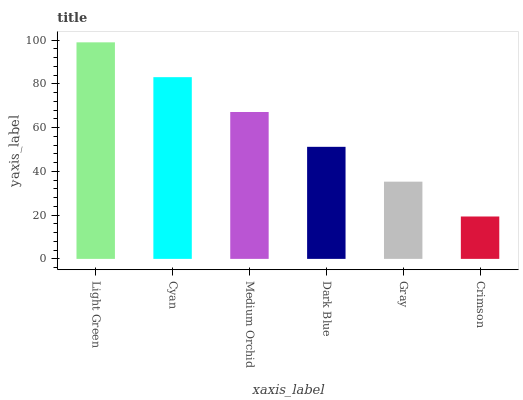Is Crimson the minimum?
Answer yes or no. Yes. Is Light Green the maximum?
Answer yes or no. Yes. Is Cyan the minimum?
Answer yes or no. No. Is Cyan the maximum?
Answer yes or no. No. Is Light Green greater than Cyan?
Answer yes or no. Yes. Is Cyan less than Light Green?
Answer yes or no. Yes. Is Cyan greater than Light Green?
Answer yes or no. No. Is Light Green less than Cyan?
Answer yes or no. No. Is Medium Orchid the high median?
Answer yes or no. Yes. Is Dark Blue the low median?
Answer yes or no. Yes. Is Dark Blue the high median?
Answer yes or no. No. Is Gray the low median?
Answer yes or no. No. 